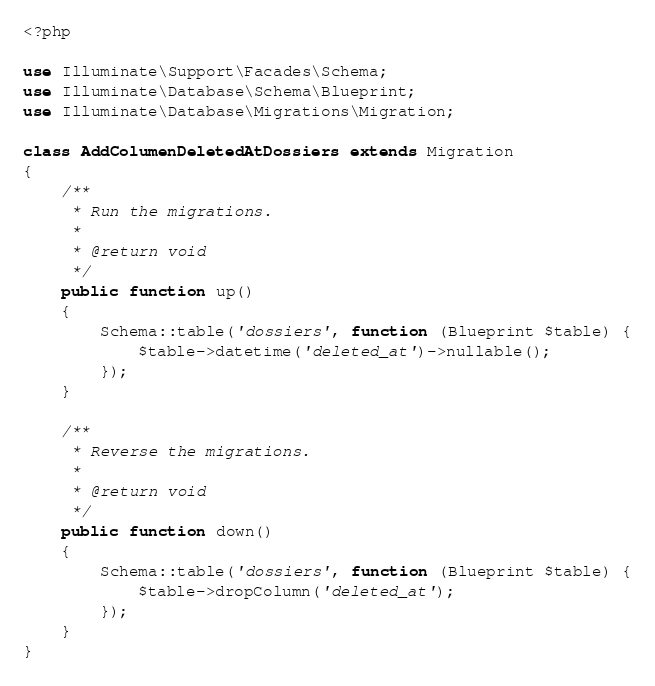Convert code to text. <code><loc_0><loc_0><loc_500><loc_500><_PHP_><?php

use Illuminate\Support\Facades\Schema;
use Illuminate\Database\Schema\Blueprint;
use Illuminate\Database\Migrations\Migration;

class AddColumenDeletedAtDossiers extends Migration
{
    /**
     * Run the migrations.
     *
     * @return void
     */
    public function up()
    {
        Schema::table('dossiers', function (Blueprint $table) {
            $table->datetime('deleted_at')->nullable();
        });
    }

    /**
     * Reverse the migrations.
     *
     * @return void
     */
    public function down()
    {
        Schema::table('dossiers', function (Blueprint $table) {
            $table->dropColumn('deleted_at');
        });
    }
}
</code> 